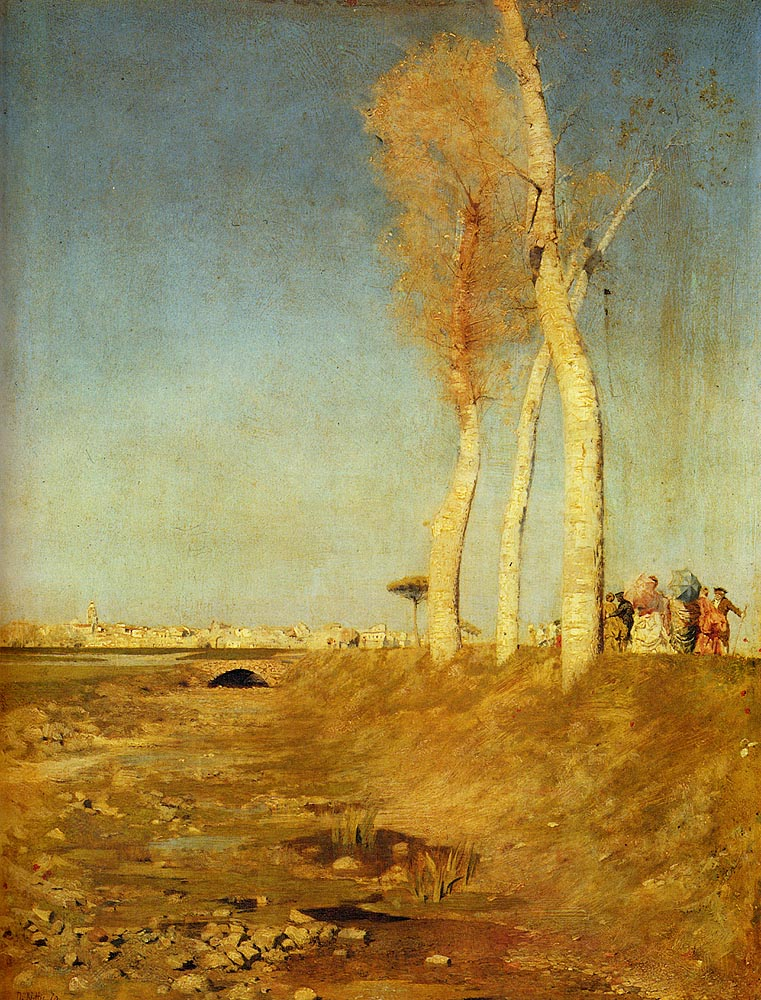Analyze the image in a comprehensive and detailed manner. This painting, known as 'The Lackawanna Valley', is an oil on canvas that captures an early American rural landscape intertwined with burgeoning industrial elements. The foreground features rough terrain and sparse vegetation. Notably, birch trees, characterized by their distinctive bark, stand prominently. In the middle ground, remnants of a river or brook suggest a natural landscape undergoing change. The background subtly introduces an industrial theme with smokestacks that barely pierce the horizon, suggesting the onset of industrialization amidst the natural setting. This artwork captures a moment of transition where nature and industrialization coexist in the early stages of modern America. 